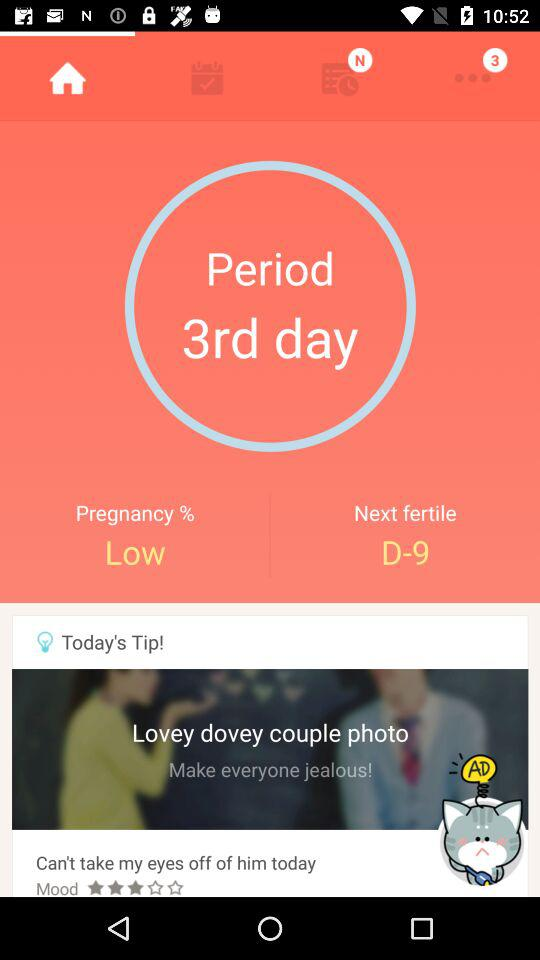What day of the period is it? It is the third day of the period. 